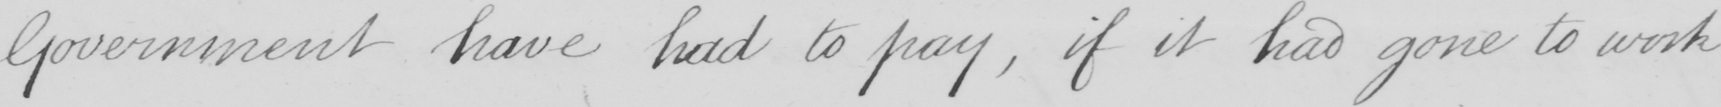What is written in this line of handwriting? Government have had to pay , if it had gone to work 